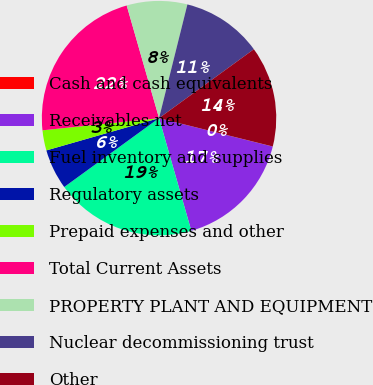<chart> <loc_0><loc_0><loc_500><loc_500><pie_chart><fcel>Cash and cash equivalents<fcel>Receivables net<fcel>Fuel inventory and supplies<fcel>Regulatory assets<fcel>Prepaid expenses and other<fcel>Total Current Assets<fcel>PROPERTY PLANT AND EQUIPMENT<fcel>Nuclear decommissioning trust<fcel>Other<nl><fcel>0.01%<fcel>16.66%<fcel>19.44%<fcel>5.56%<fcel>2.78%<fcel>22.21%<fcel>8.34%<fcel>11.11%<fcel>13.89%<nl></chart> 